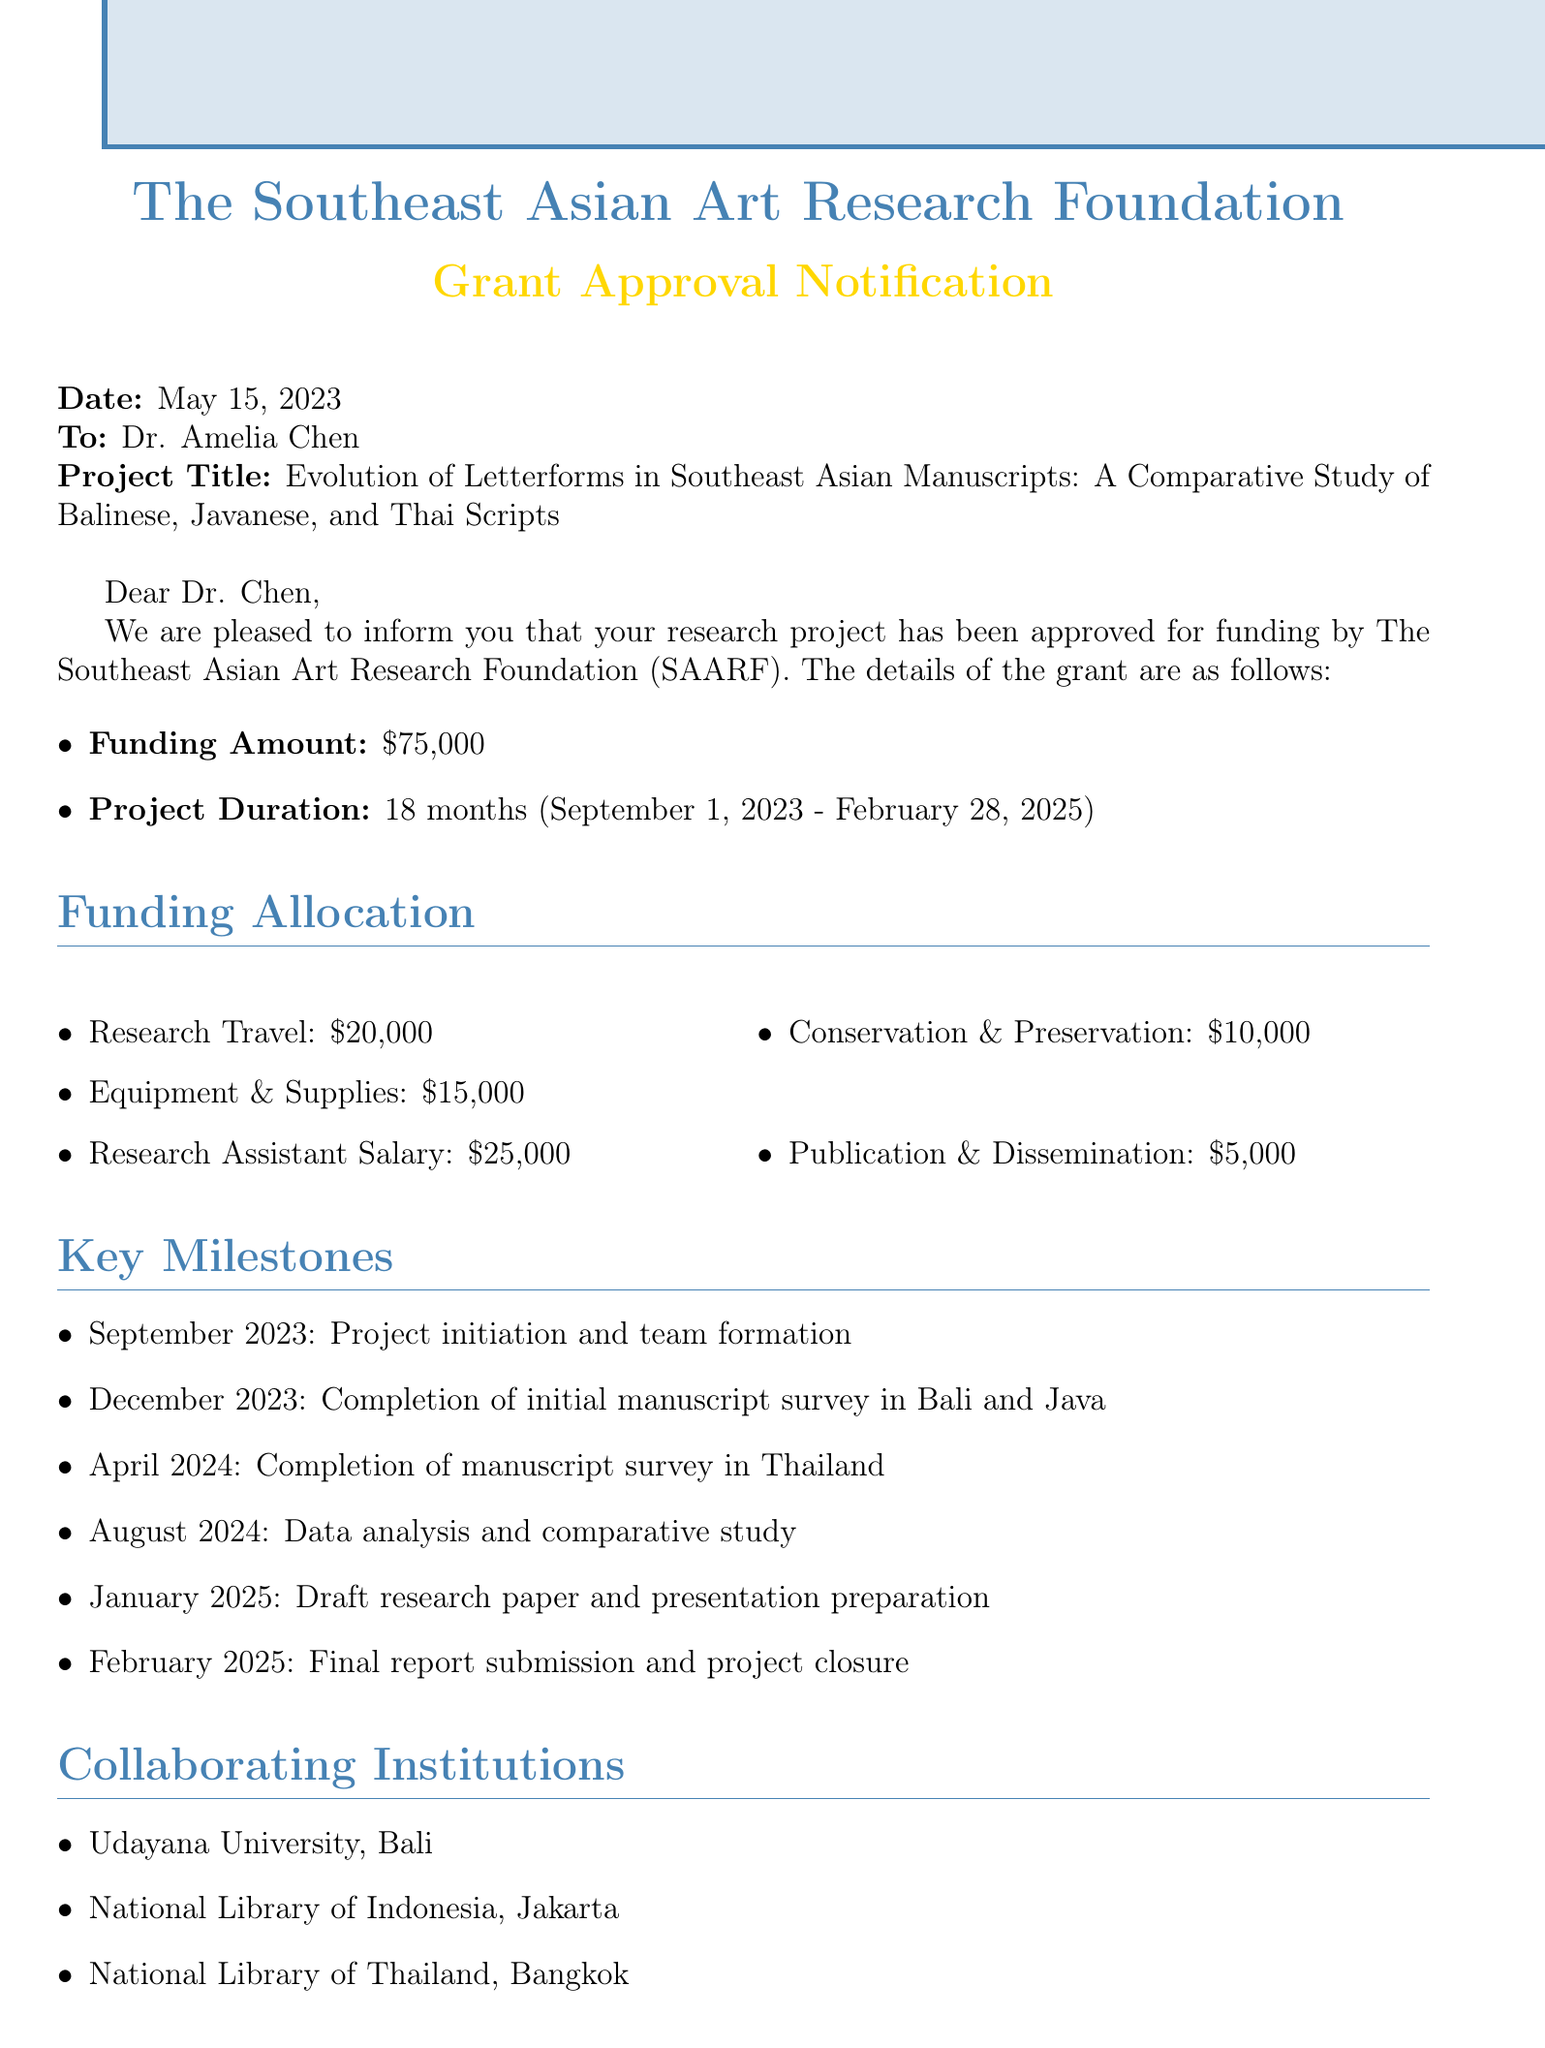What is the granting institution? The granting institution is mentioned at the beginning of the document and is The Southeast Asian Art Research Foundation.
Answer: The Southeast Asian Art Research Foundation (SAARF) Who is the recipient of the grant? The recipient's name is clearly stated in the salutation of the document.
Answer: Dr. Amelia Chen What is the project title? The project title is explicitly mentioned in the document following the recipient's name.
Answer: Evolution of Letterforms in Southeast Asian Manuscripts: A Comparative Study of Balinese, Javanese, and Thai Scripts What is the approved funding amount? The funding amount is specified in the details of the grant.
Answer: $75,000 How long is the project duration? The project duration is detailed in the grant approval section.
Answer: 18 months (September 1, 2023 - February 28, 2025) What is allocated for research travel? The funding allocation for research travel is listed under the funding allocation section.
Answer: $20,000 When is the mid-project review scheduled? The mid-project review date is stated under reporting requirements.
Answer: March 2024 Which institution is collaborating from Thailand? The collaborating institutions list includes the collaborating institution from Thailand.
Answer: National Library of Thailand, Bangkok What is the first key milestone in the project timeline? The first key milestone is detailed in the key milestones section of the document.
Answer: September 2023: Project initiation and team formation What is the final report submission date? The final report submission date is noted in the key milestones section.
Answer: February 2025 